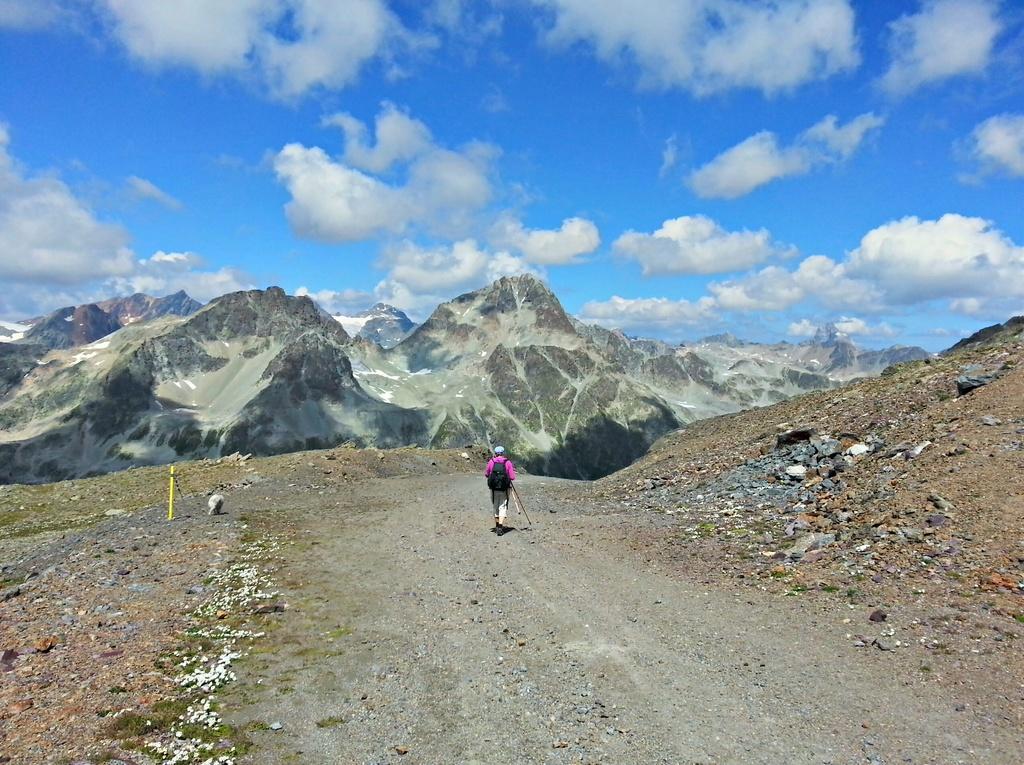Could you give a brief overview of what you see in this image? In this picture I can see a person with a backpack, there are rocks, there are mountains, and in the background there is the sky. 